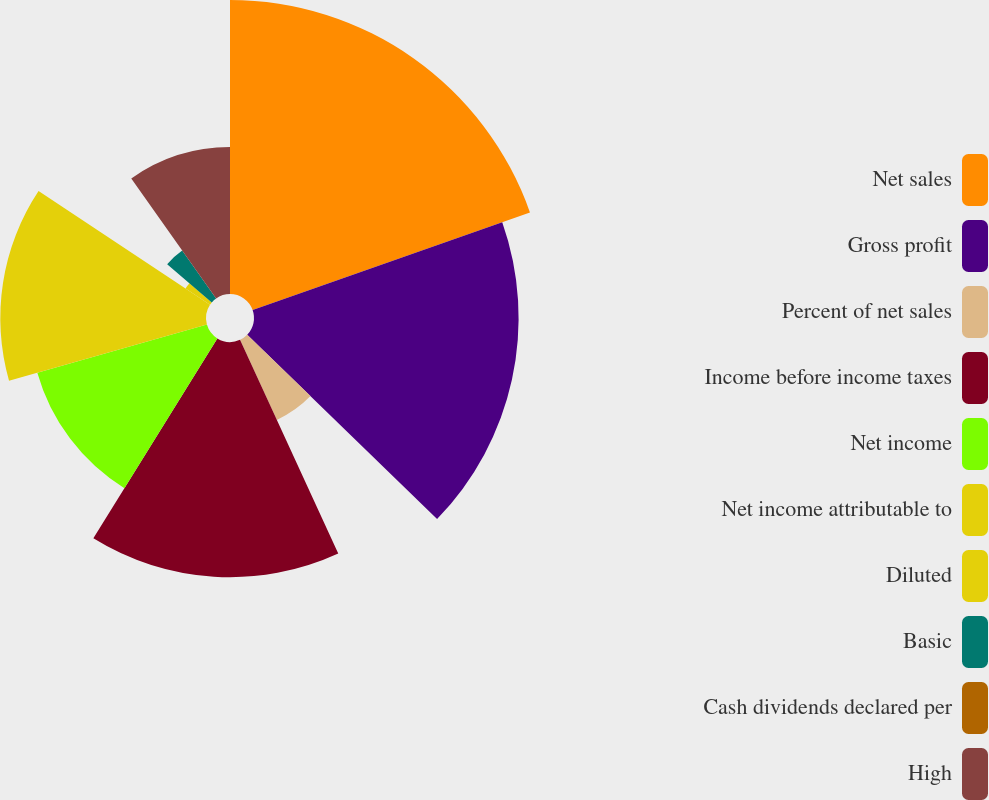Convert chart. <chart><loc_0><loc_0><loc_500><loc_500><pie_chart><fcel>Net sales<fcel>Gross profit<fcel>Percent of net sales<fcel>Income before income taxes<fcel>Net income<fcel>Net income attributable to<fcel>Diluted<fcel>Basic<fcel>Cash dividends declared per<fcel>High<nl><fcel>19.61%<fcel>17.65%<fcel>5.88%<fcel>15.69%<fcel>11.76%<fcel>13.72%<fcel>1.96%<fcel>3.92%<fcel>0.0%<fcel>9.8%<nl></chart> 